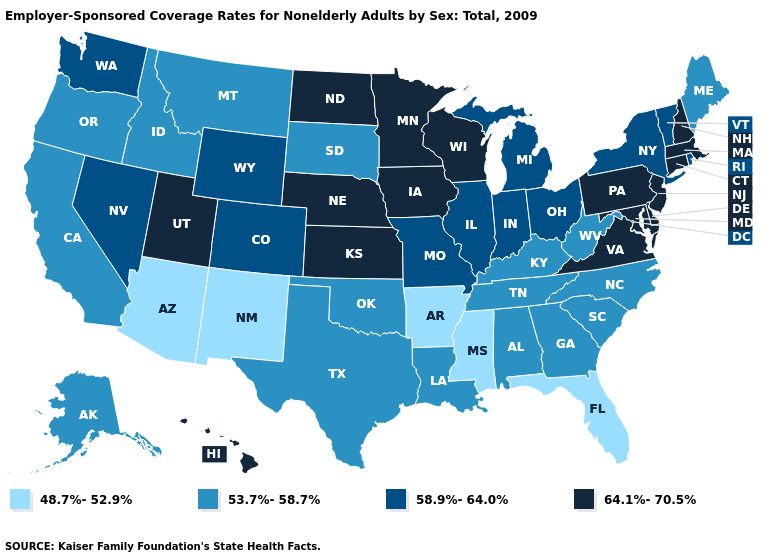Name the states that have a value in the range 53.7%-58.7%?
Quick response, please. Alabama, Alaska, California, Georgia, Idaho, Kentucky, Louisiana, Maine, Montana, North Carolina, Oklahoma, Oregon, South Carolina, South Dakota, Tennessee, Texas, West Virginia. What is the value of Montana?
Keep it brief. 53.7%-58.7%. Does New Jersey have the lowest value in the Northeast?
Write a very short answer. No. What is the highest value in the USA?
Be succinct. 64.1%-70.5%. Does Delaware have the highest value in the South?
Be succinct. Yes. Does New Jersey have the same value as Mississippi?
Keep it brief. No. Which states hav the highest value in the Northeast?
Concise answer only. Connecticut, Massachusetts, New Hampshire, New Jersey, Pennsylvania. Among the states that border Texas , does Louisiana have the lowest value?
Concise answer only. No. Name the states that have a value in the range 58.9%-64.0%?
Short answer required. Colorado, Illinois, Indiana, Michigan, Missouri, Nevada, New York, Ohio, Rhode Island, Vermont, Washington, Wyoming. What is the lowest value in the MidWest?
Short answer required. 53.7%-58.7%. Does Kentucky have the highest value in the South?
Keep it brief. No. What is the value of Idaho?
Concise answer only. 53.7%-58.7%. Among the states that border Arizona , does New Mexico have the lowest value?
Give a very brief answer. Yes. Does Nebraska have the highest value in the USA?
Answer briefly. Yes. What is the highest value in states that border Rhode Island?
Short answer required. 64.1%-70.5%. 